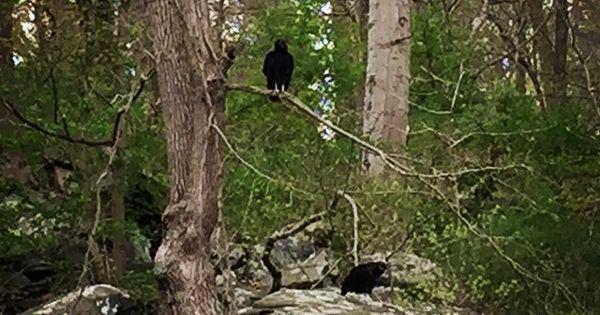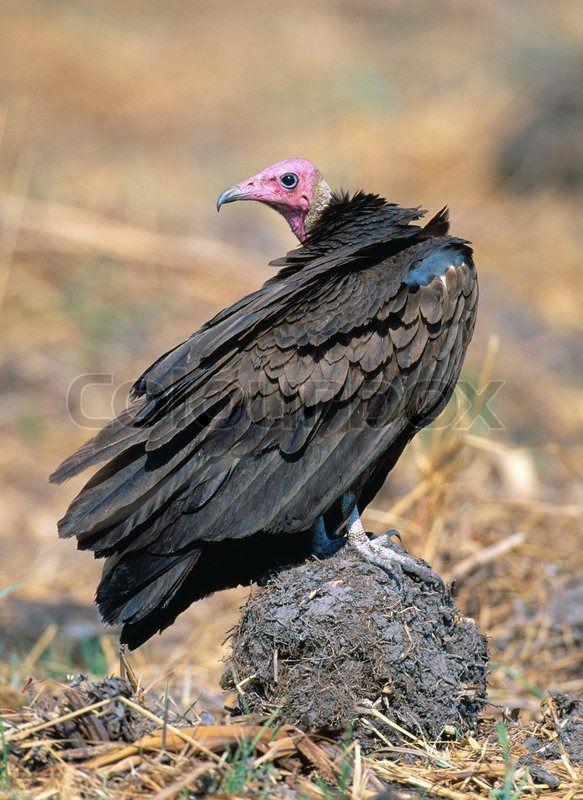The first image is the image on the left, the second image is the image on the right. Considering the images on both sides, is "There is exactly one bird in one of the images." valid? Answer yes or no. Yes. 